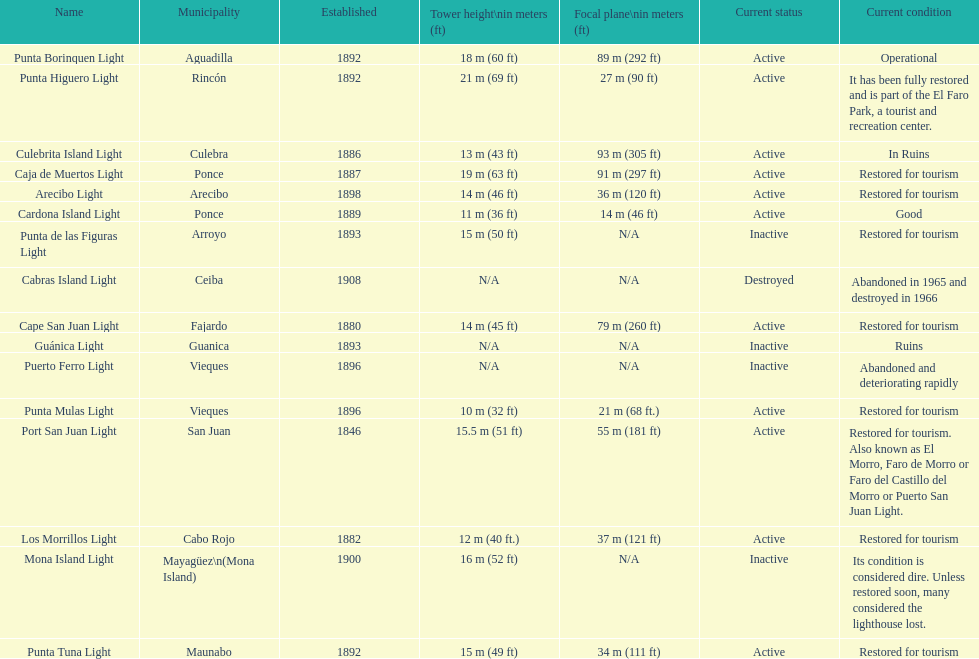Were any towers established before the year 1800? No. Parse the table in full. {'header': ['Name', 'Municipality', 'Established', 'Tower height\\nin meters (ft)', 'Focal plane\\nin meters (ft)', 'Current status', 'Current condition'], 'rows': [['Punta Borinquen Light', 'Aguadilla', '1892', '18\xa0m (60\xa0ft)', '89\xa0m (292\xa0ft)', 'Active', 'Operational'], ['Punta Higuero Light', 'Rincón', '1892', '21\xa0m (69\xa0ft)', '27\xa0m (90\xa0ft)', 'Active', 'It has been fully restored and is part of the El Faro Park, a tourist and recreation center.'], ['Culebrita Island Light', 'Culebra', '1886', '13\xa0m (43\xa0ft)', '93\xa0m (305\xa0ft)', 'Active', 'In Ruins'], ['Caja de Muertos Light', 'Ponce', '1887', '19\xa0m (63\xa0ft)', '91\xa0m (297\xa0ft)', 'Active', 'Restored for tourism'], ['Arecibo Light', 'Arecibo', '1898', '14\xa0m (46\xa0ft)', '36\xa0m (120\xa0ft)', 'Active', 'Restored for tourism'], ['Cardona Island Light', 'Ponce', '1889', '11\xa0m (36\xa0ft)', '14\xa0m (46\xa0ft)', 'Active', 'Good'], ['Punta de las Figuras Light', 'Arroyo', '1893', '15\xa0m (50\xa0ft)', 'N/A', 'Inactive', 'Restored for tourism'], ['Cabras Island Light', 'Ceiba', '1908', 'N/A', 'N/A', 'Destroyed', 'Abandoned in 1965 and destroyed in 1966'], ['Cape San Juan Light', 'Fajardo', '1880', '14\xa0m (45\xa0ft)', '79\xa0m (260\xa0ft)', 'Active', 'Restored for tourism'], ['Guánica Light', 'Guanica', '1893', 'N/A', 'N/A', 'Inactive', 'Ruins'], ['Puerto Ferro Light', 'Vieques', '1896', 'N/A', 'N/A', 'Inactive', 'Abandoned and deteriorating rapidly'], ['Punta Mulas Light', 'Vieques', '1896', '10\xa0m (32\xa0ft)', '21\xa0m (68\xa0ft.)', 'Active', 'Restored for tourism'], ['Port San Juan Light', 'San Juan', '1846', '15.5\xa0m (51\xa0ft)', '55\xa0m (181\xa0ft)', 'Active', 'Restored for tourism. Also known as El Morro, Faro de Morro or Faro del Castillo del Morro or Puerto San Juan Light.'], ['Los Morrillos Light', 'Cabo Rojo', '1882', '12\xa0m (40\xa0ft.)', '37\xa0m (121\xa0ft)', 'Active', 'Restored for tourism'], ['Mona Island Light', 'Mayagüez\\n(Mona Island)', '1900', '16\xa0m (52\xa0ft)', 'N/A', 'Inactive', 'Its condition is considered dire. Unless restored soon, many considered the lighthouse lost.'], ['Punta Tuna Light', 'Maunabo', '1892', '15\xa0m (49\xa0ft)', '34\xa0m (111\xa0ft)', 'Active', 'Restored for tourism']]} 